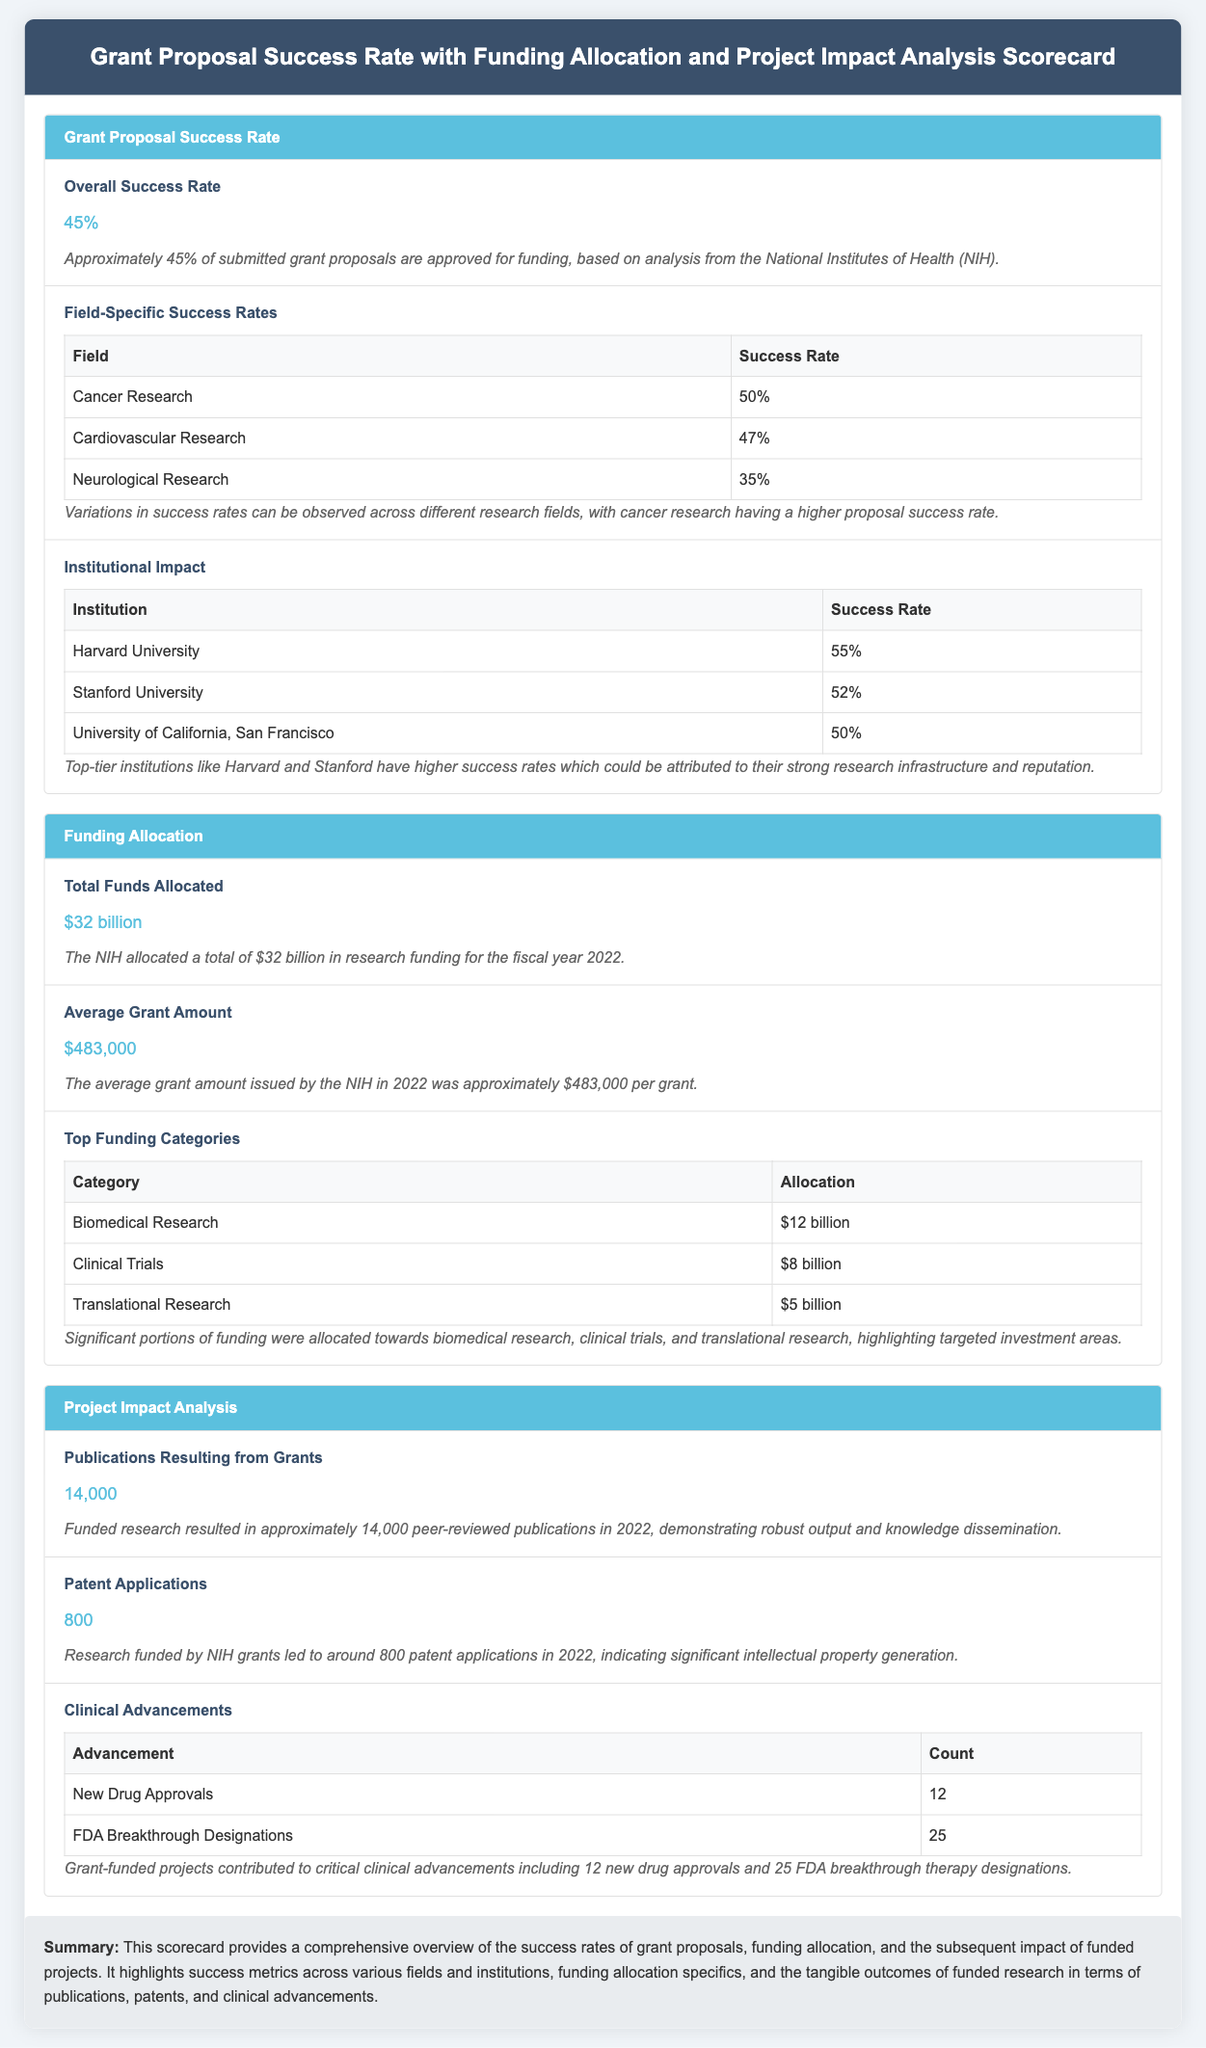What is the overall success rate of grant proposals? The overall success rate is provided in the document under the Grant Proposal Success Rate section, stating that 45% of submitted grant proposals are approved for funding.
Answer: 45% Which research field has the highest success rate? The field-specific success rates in the document indicate that Cancer Research has the highest success rate at 50%.
Answer: Cancer Research How much total funds were allocated for research in 2022? The total funds allocated is mentioned in the Funding Allocation section, indicating that $32 billion was allocated by the NIH for the fiscal year 2022.
Answer: $32 billion What is the average grant amount issued by NIH in 2022? The average grant amount is specifically stated in the Funding Allocation section as approximately $483,000 per grant.
Answer: $483,000 How many publications resulted from funded grants in 2022? The document indicates that approximately 14,000 peer-reviewed publications resulted from funded research in 2022 under the Project Impact Analysis section.
Answer: 14,000 Which institution has the highest grant proposal success rate? In the Institutional Impact table, Harvard University is noted as having the highest success rate at 55%.
Answer: Harvard University What were the counts of new drug approvals and FDA breakthrough designations? The Clinical Advancements section provides specific counts, stating there were 12 new drug approvals and 25 FDA breakthrough designations from NIH-funded projects in 2022.
Answer: 12 and 25 What is the total funding allocated for Biomedical Research? The document specifies in the Top Funding Categories table that $12 billion was allocated for Biomedical Research.
Answer: $12 billion What type of advancements did grant-funded projects contribute to? The Project Impact Analysis section mentions clinical advancements including new drug approvals and FDA breakthrough designations.
Answer: New Drug Approvals and FDA Breakthrough Designations 